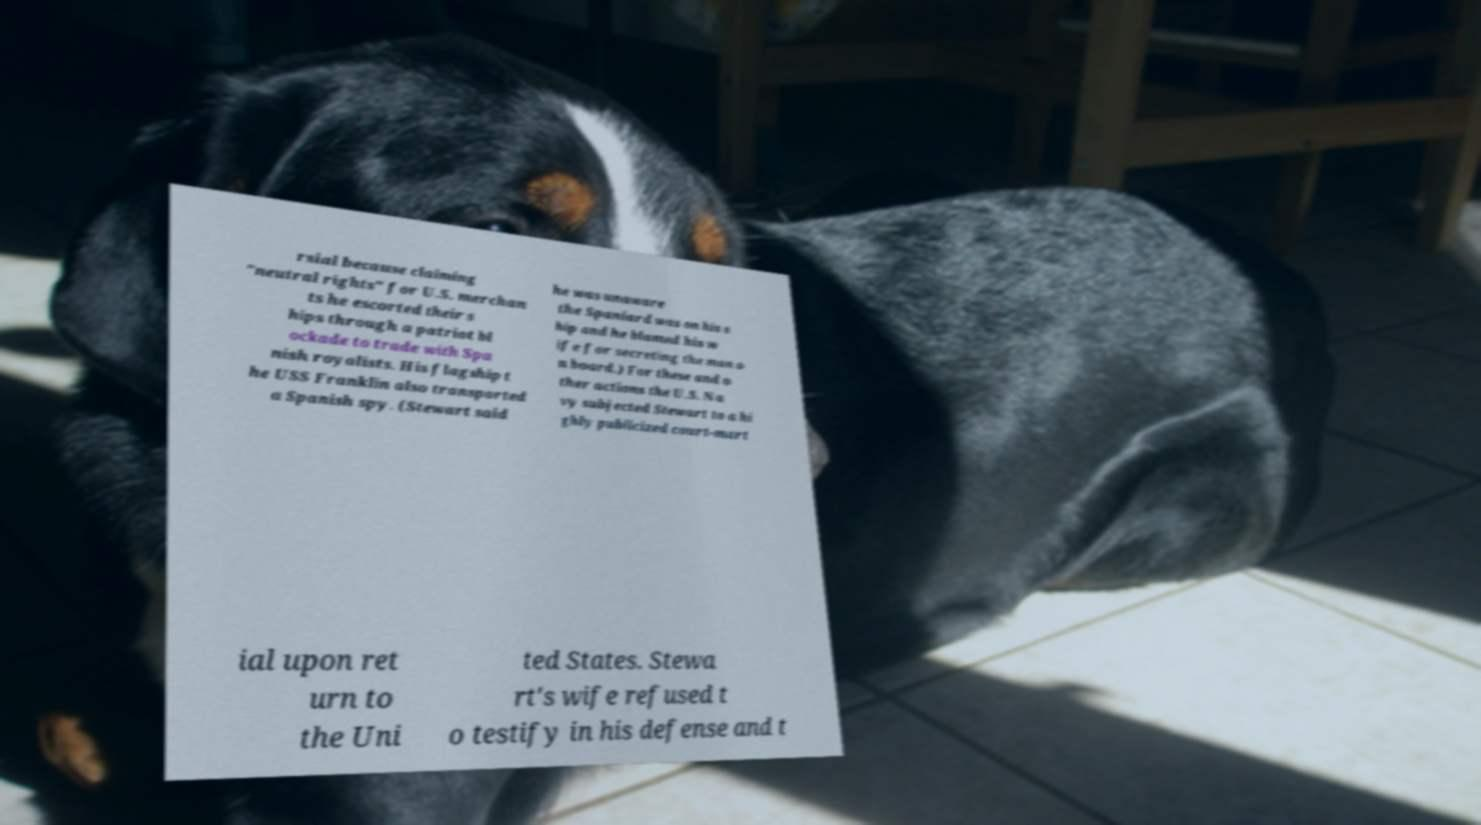Can you read and provide the text displayed in the image?This photo seems to have some interesting text. Can you extract and type it out for me? rsial because claiming "neutral rights" for U.S. merchan ts he escorted their s hips through a patriot bl ockade to trade with Spa nish royalists. His flagship t he USS Franklin also transported a Spanish spy. (Stewart said he was unaware the Spaniard was on his s hip and he blamed his w ife for secreting the man o n board.) For these and o ther actions the U.S. Na vy subjected Stewart to a hi ghly publicized court-mart ial upon ret urn to the Uni ted States. Stewa rt's wife refused t o testify in his defense and t 